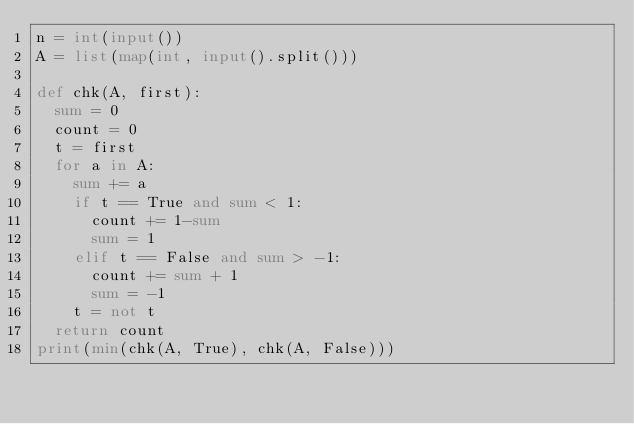<code> <loc_0><loc_0><loc_500><loc_500><_Python_>n = int(input())
A = list(map(int, input().split()))

def chk(A, first):
  sum = 0
  count = 0
  t = first
  for a in A:
    sum += a
    if t == True and sum < 1:
      count += 1-sum
      sum = 1
    elif t == False and sum > -1:
      count += sum + 1
      sum = -1
    t = not t
  return count
print(min(chk(A, True), chk(A, False)))</code> 